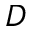<formula> <loc_0><loc_0><loc_500><loc_500>D</formula> 